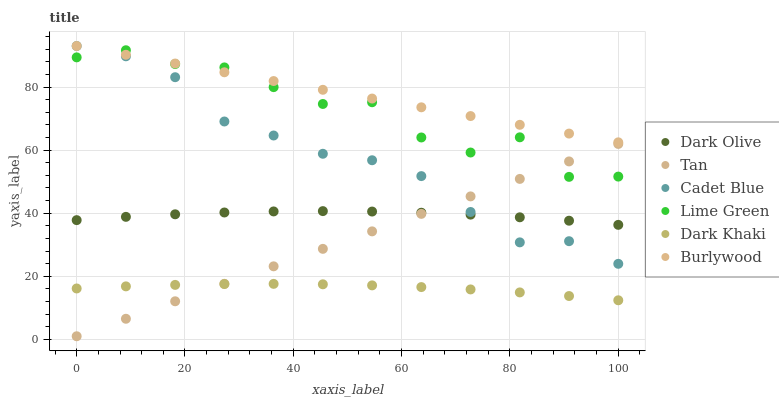Does Dark Khaki have the minimum area under the curve?
Answer yes or no. Yes. Does Burlywood have the maximum area under the curve?
Answer yes or no. Yes. Does Dark Olive have the minimum area under the curve?
Answer yes or no. No. Does Dark Olive have the maximum area under the curve?
Answer yes or no. No. Is Tan the smoothest?
Answer yes or no. Yes. Is Lime Green the roughest?
Answer yes or no. Yes. Is Burlywood the smoothest?
Answer yes or no. No. Is Burlywood the roughest?
Answer yes or no. No. Does Tan have the lowest value?
Answer yes or no. Yes. Does Dark Olive have the lowest value?
Answer yes or no. No. Does Burlywood have the highest value?
Answer yes or no. Yes. Does Dark Olive have the highest value?
Answer yes or no. No. Is Dark Khaki less than Burlywood?
Answer yes or no. Yes. Is Lime Green greater than Dark Olive?
Answer yes or no. Yes. Does Cadet Blue intersect Burlywood?
Answer yes or no. Yes. Is Cadet Blue less than Burlywood?
Answer yes or no. No. Is Cadet Blue greater than Burlywood?
Answer yes or no. No. Does Dark Khaki intersect Burlywood?
Answer yes or no. No. 